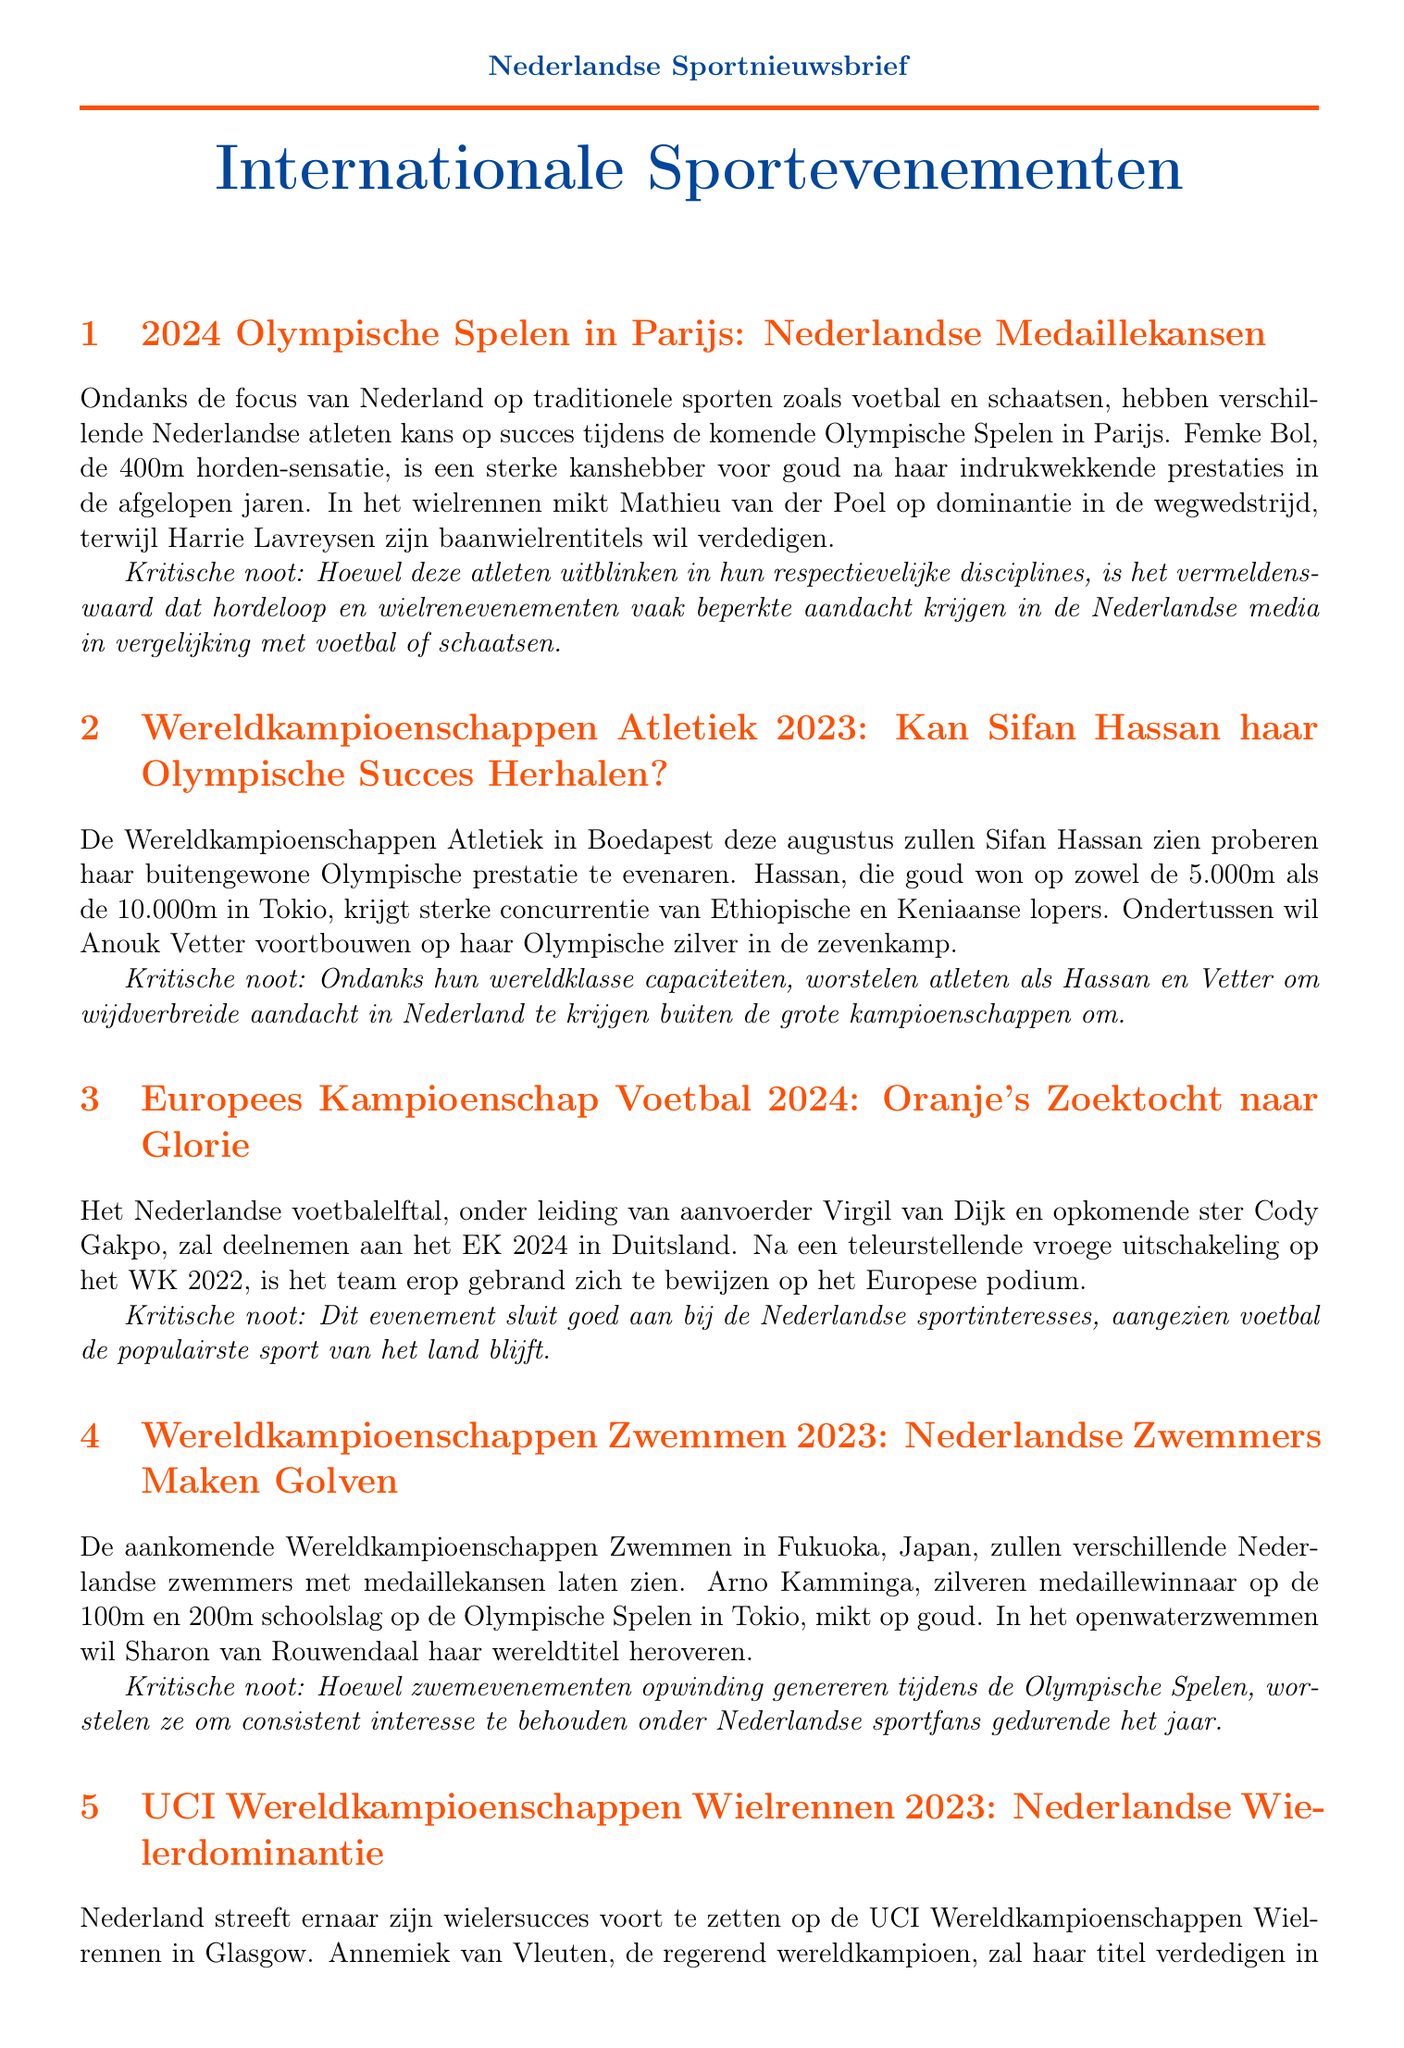what is the venue for the 2023 World Athletics Championships? The venue for the 2023 World Athletics Championships is Budapest.
Answer: Budapest who is aiming to defend titles in track cycling? The athlete aiming to defend titles in track cycling is Harrie Lavreysen.
Answer: Harrie Lavreysen how many gold medals did Sifan Hassan win in Tokyo? Sifan Hassan won two gold medals in Tokyo, one in the 5,000m and one in the 10,000m.
Answer: two which Dutch swimmer is looking to reclaim a world title? The Dutch swimmer looking to reclaim a world title is Sharon van Rouwendaal.
Answer: Sharon van Rouwendaal what is the focus of the Netherlands' sporting interests? The focus of the Netherlands' sporting interests is on traditional sports like football and speed skating.
Answer: football and speed skating who are the favorites in the men's road race at the UCI Road World Championships? The favorites in the men's road race are Mathieu van der Poel and Wout van Aert.
Answer: Mathieu van der Poel and Wout van Aert what critical note is mentioned about swimming events? The critical note mentions that swimming events struggle to maintain consistent interest among Dutch sports fans.
Answer: consistent interest what medal did Anouk Vetter win in the heptathlon at the Olympics? Anouk Vetter won a silver medal in the heptathlon at the Olympics.
Answer: silver what is the date of the Euro 2024? The document does not provide the exact date for Euro 2024.
Answer: not specified 